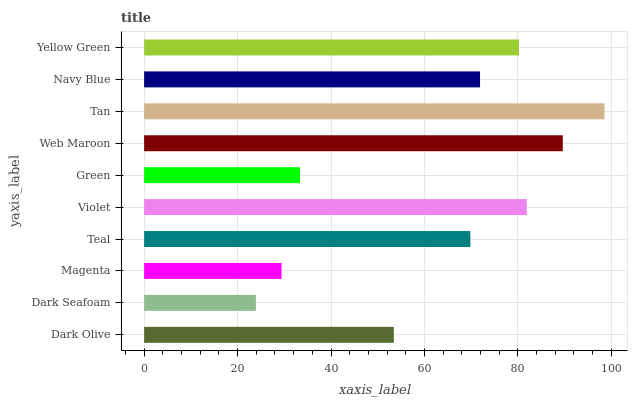Is Dark Seafoam the minimum?
Answer yes or no. Yes. Is Tan the maximum?
Answer yes or no. Yes. Is Magenta the minimum?
Answer yes or no. No. Is Magenta the maximum?
Answer yes or no. No. Is Magenta greater than Dark Seafoam?
Answer yes or no. Yes. Is Dark Seafoam less than Magenta?
Answer yes or no. Yes. Is Dark Seafoam greater than Magenta?
Answer yes or no. No. Is Magenta less than Dark Seafoam?
Answer yes or no. No. Is Navy Blue the high median?
Answer yes or no. Yes. Is Teal the low median?
Answer yes or no. Yes. Is Tan the high median?
Answer yes or no. No. Is Navy Blue the low median?
Answer yes or no. No. 